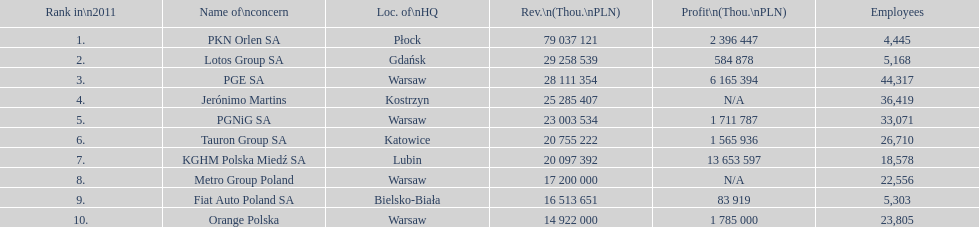What company has the top number of employees? PGE SA. 